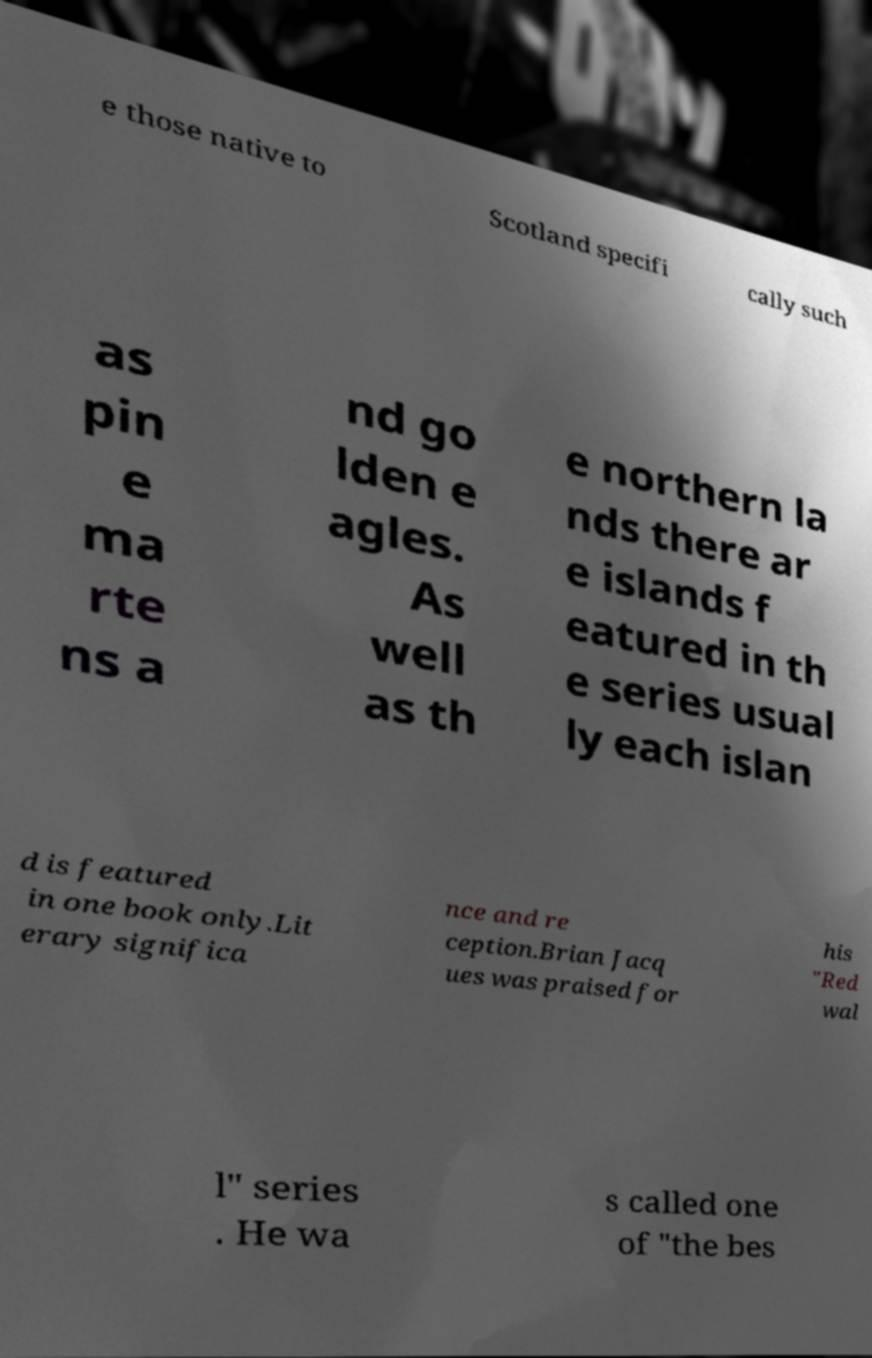Could you assist in decoding the text presented in this image and type it out clearly? e those native to Scotland specifi cally such as pin e ma rte ns a nd go lden e agles. As well as th e northern la nds there ar e islands f eatured in th e series usual ly each islan d is featured in one book only.Lit erary significa nce and re ception.Brian Jacq ues was praised for his "Red wal l" series . He wa s called one of "the bes 